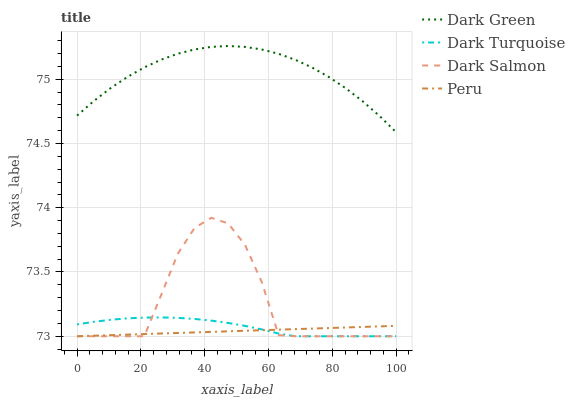Does Dark Salmon have the minimum area under the curve?
Answer yes or no. No. Does Dark Salmon have the maximum area under the curve?
Answer yes or no. No. Is Dark Salmon the smoothest?
Answer yes or no. No. Is Peru the roughest?
Answer yes or no. No. Does Dark Green have the lowest value?
Answer yes or no. No. Does Dark Salmon have the highest value?
Answer yes or no. No. Is Peru less than Dark Green?
Answer yes or no. Yes. Is Dark Green greater than Dark Salmon?
Answer yes or no. Yes. Does Peru intersect Dark Green?
Answer yes or no. No. 